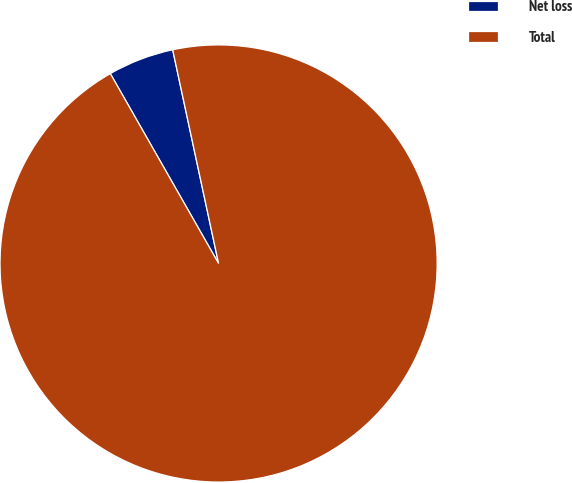<chart> <loc_0><loc_0><loc_500><loc_500><pie_chart><fcel>Net loss<fcel>Total<nl><fcel>4.88%<fcel>95.12%<nl></chart> 